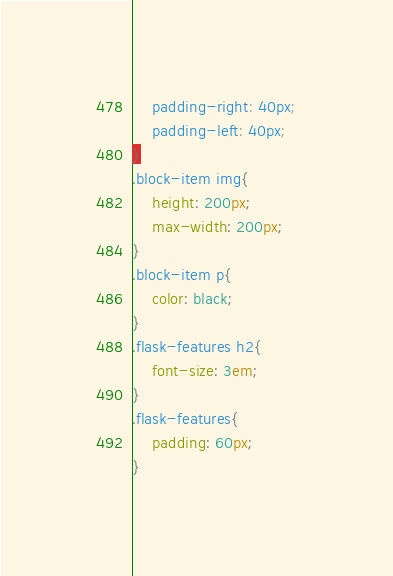<code> <loc_0><loc_0><loc_500><loc_500><_CSS_>    padding-right: 40px;
    padding-left: 40px;
}
.block-item img{
    height: 200px;
    max-width: 200px;
}
.block-item p{
    color: black;
}
.flask-features h2{
    font-size: 3em;
}
.flask-features{
    padding: 60px;
}</code> 